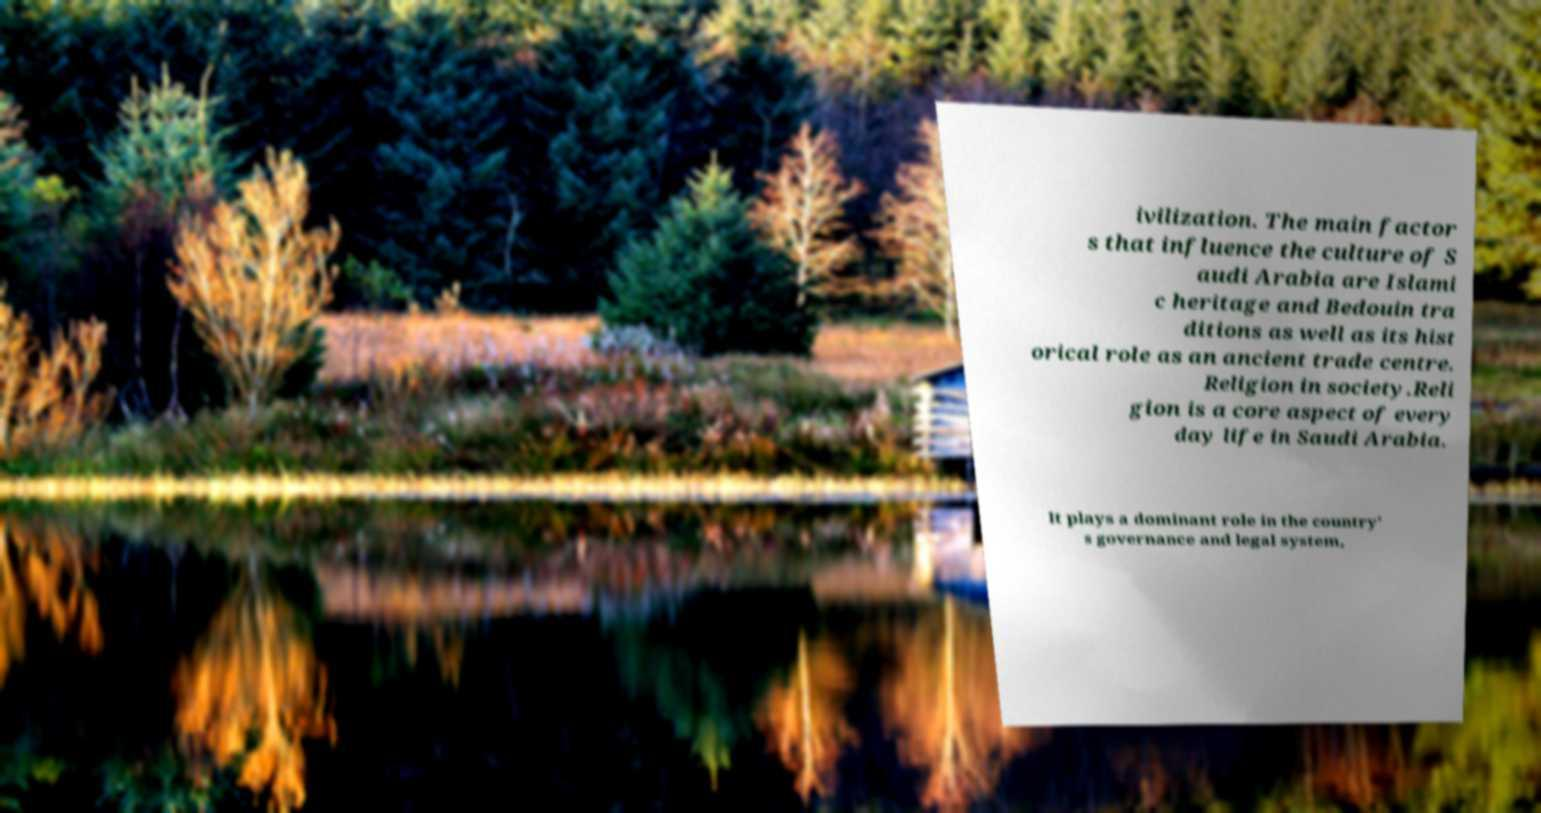For documentation purposes, I need the text within this image transcribed. Could you provide that? ivilization. The main factor s that influence the culture of S audi Arabia are Islami c heritage and Bedouin tra ditions as well as its hist orical role as an ancient trade centre. Religion in society.Reli gion is a core aspect of every day life in Saudi Arabia. It plays a dominant role in the country' s governance and legal system, 